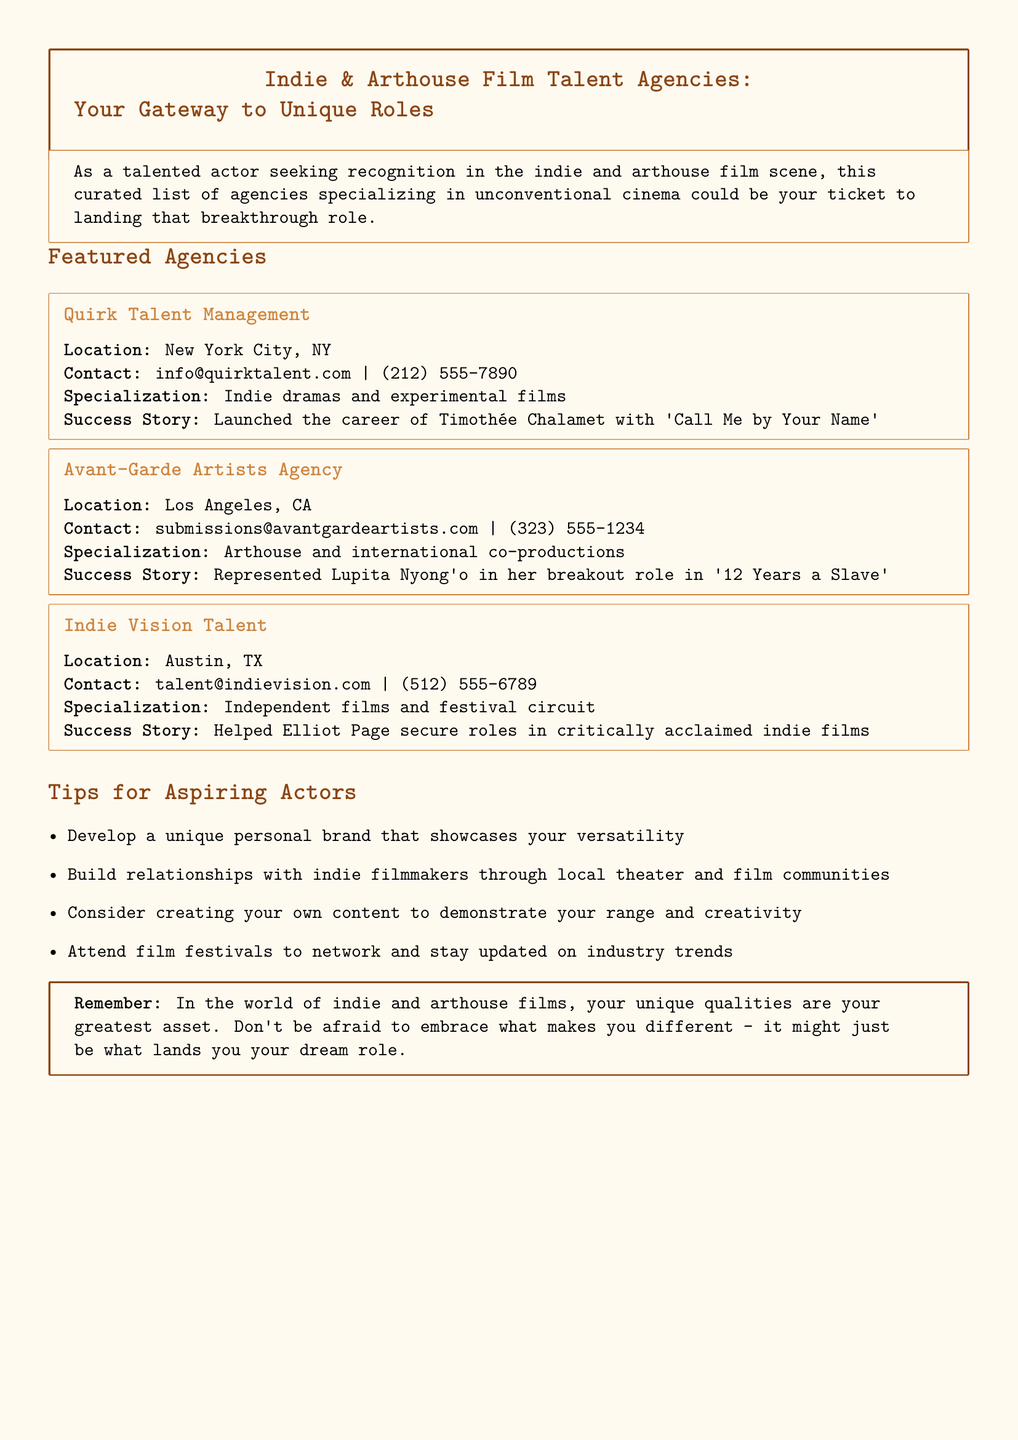What is the location of Quirk Talent Management? The document states that Quirk Talent Management is located in New York City, NY.
Answer: New York City, NY What is the specialization of Avant-Garde Artists Agency? The specialization of Avant-Garde Artists Agency is mentioned as arthouse and international co-productions.
Answer: Arthouse and international co-productions Who is a success story represented by Indie Vision Talent? The document lists Elliot Page as a success story helped by Indie Vision Talent.
Answer: Elliot Page What is the contact email for Quirk Talent Management? The contact email provided for Quirk Talent Management is info@quirktalent.com.
Answer: info@quirktalent.com Which agency helped launch Timothée Chalamet's career? The document states that Quirk Talent Management launched Timothée Chalamet's career.
Answer: Quirk Talent Management What city is Indie Vision Talent located in? The document indicates that Indie Vision Talent is located in Austin, TX.
Answer: Austin, TX What type of films does Indie Vision Talent specialize in? The document notes that Indie Vision Talent specializes in independent films and the festival circuit.
Answer: Independent films and festival circuit How many agencies are featured in the document? The document lists three agencies in the featured section.
Answer: Three 